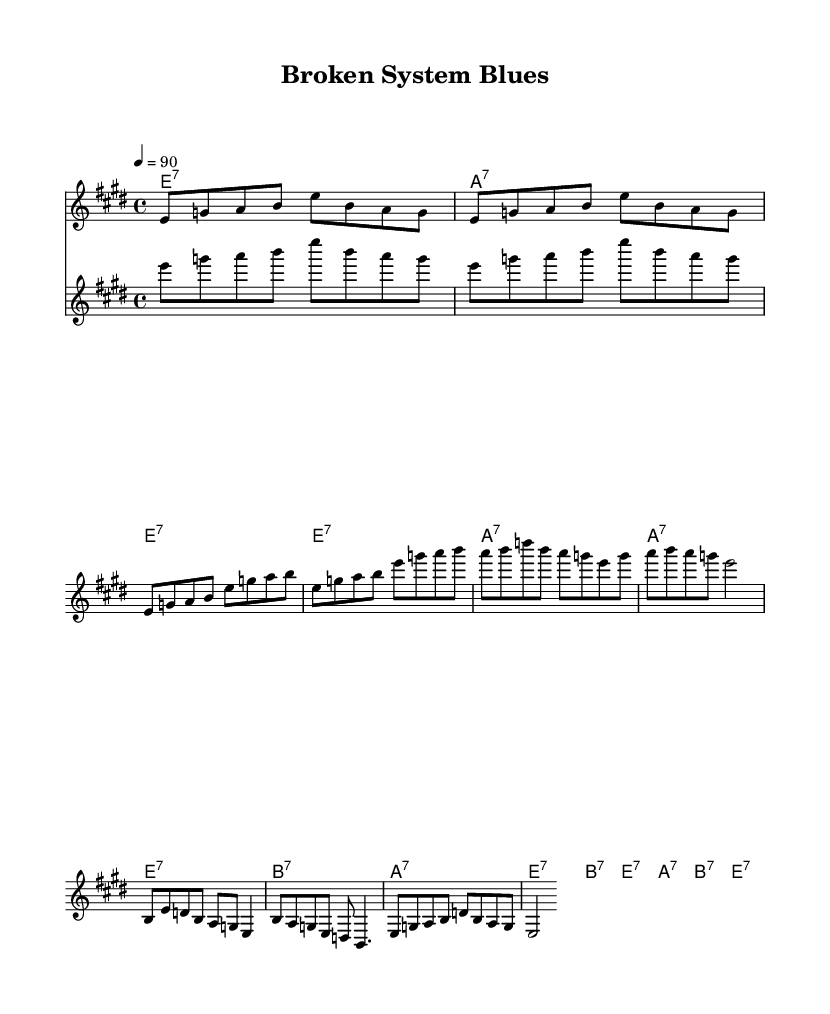What is the key signature of this music? The key signature shown is E major, which contains four sharps (F#, C#, G#, and D#). This is determined by looking at the key signature indication in the first measure.
Answer: E major What is the time signature of this piece? The time signature displayed at the beginning of the music is 4/4, which means there are four beats in each measure and the quarter note gets one beat. This is found at the start of the score before the music begins.
Answer: 4/4 What is the tempo marking for this song? The tempo marking indicates that the music should be played at a speed of 90 beats per minute, which is specified in the tempo directive at the beginning of the score.
Answer: 90 How many measures are in the verse section? The verse section contains a total of 4 measures, as can be counted by identifying the line breaks in the verse notation. Each line represents a measure in the structure.
Answer: 4 What is the main theme of the lyrics focused on? The lyrics reflect issues of social inequality and injustice, highlighting the struggles of people in urban environments versus those profiting from the system. This is interpreted from the lyrical content presented with the music.
Answer: Social inequality Which instrument plays the guitar riff? The guitar riff is played by the instrument denoted as "guitar" in the score, where the specific musical notation for the guitar is provided. This label is indicated in the staff section of the score.
Answer: Guitar What is the structure of the song? The structure of the song follows a verse-chorus format, alternating between the verse and the chorus sections. This can be identified by the layout of the music indicating where each section starts and ends.
Answer: Verse-Chorus 